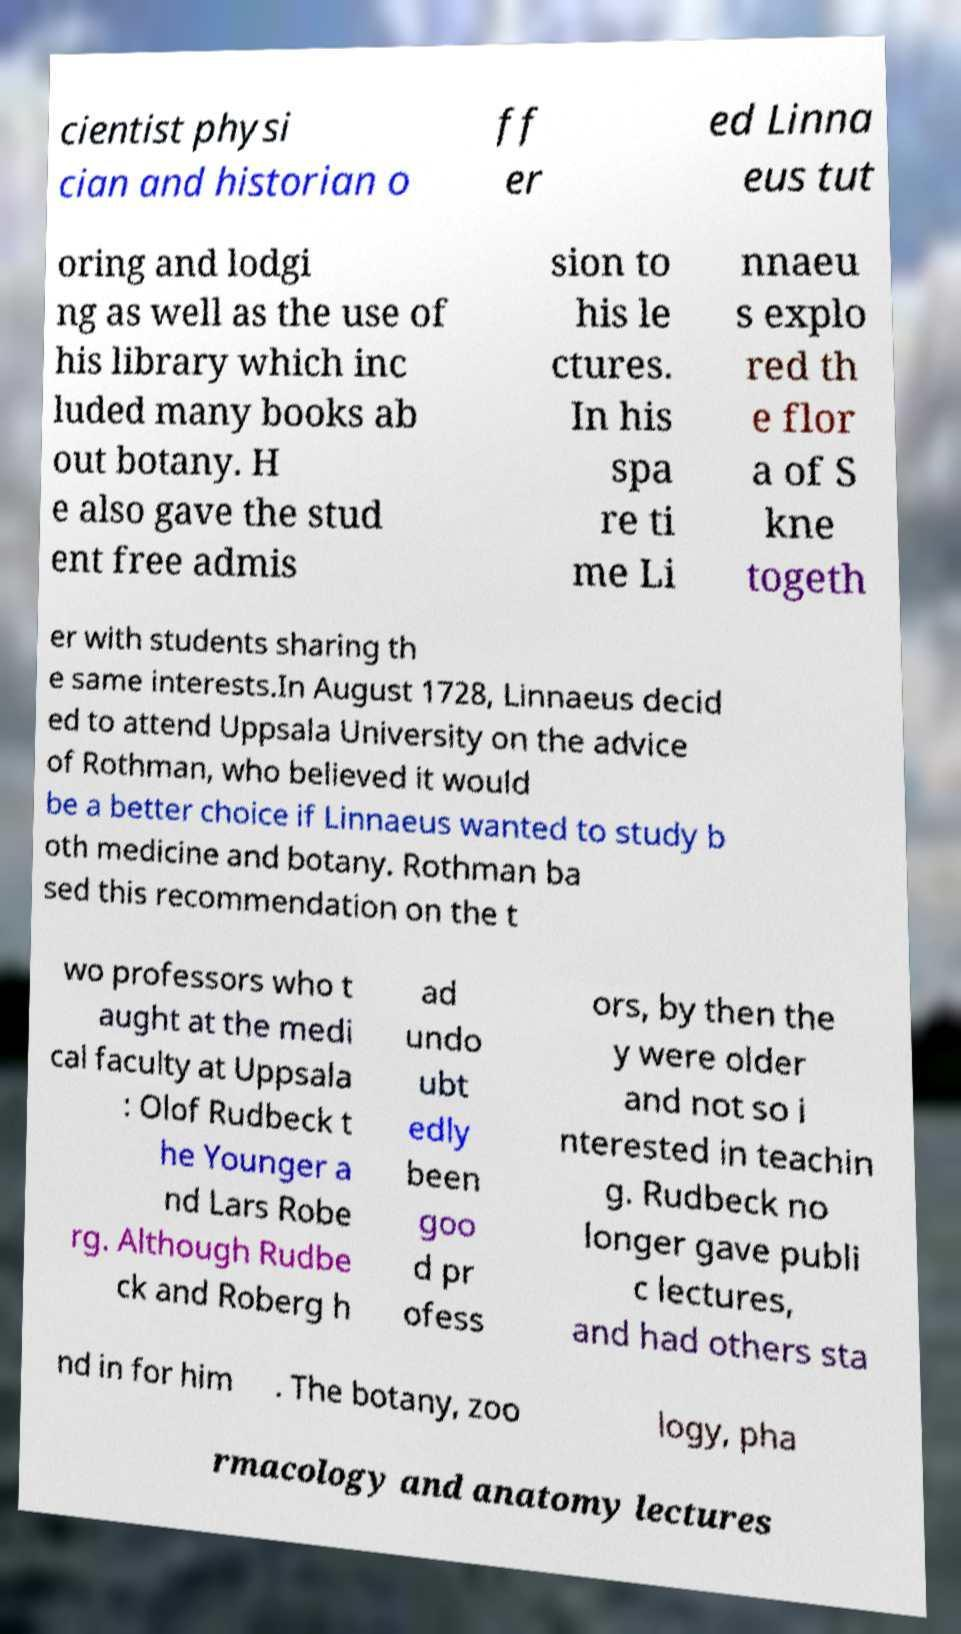Please identify and transcribe the text found in this image. cientist physi cian and historian o ff er ed Linna eus tut oring and lodgi ng as well as the use of his library which inc luded many books ab out botany. H e also gave the stud ent free admis sion to his le ctures. In his spa re ti me Li nnaeu s explo red th e flor a of S kne togeth er with students sharing th e same interests.In August 1728, Linnaeus decid ed to attend Uppsala University on the advice of Rothman, who believed it would be a better choice if Linnaeus wanted to study b oth medicine and botany. Rothman ba sed this recommendation on the t wo professors who t aught at the medi cal faculty at Uppsala : Olof Rudbeck t he Younger a nd Lars Robe rg. Although Rudbe ck and Roberg h ad undo ubt edly been goo d pr ofess ors, by then the y were older and not so i nterested in teachin g. Rudbeck no longer gave publi c lectures, and had others sta nd in for him . The botany, zoo logy, pha rmacology and anatomy lectures 